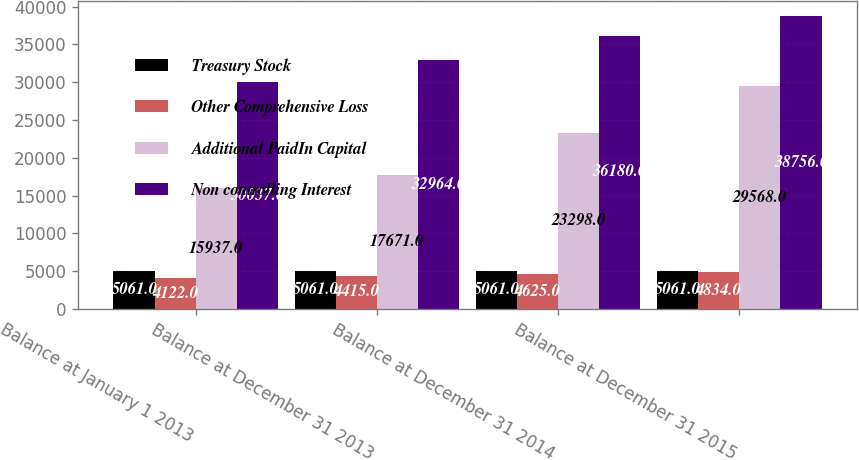Convert chart to OTSL. <chart><loc_0><loc_0><loc_500><loc_500><stacked_bar_chart><ecel><fcel>Balance at January 1 2013<fcel>Balance at December 31 2013<fcel>Balance at December 31 2014<fcel>Balance at December 31 2015<nl><fcel>Treasury Stock<fcel>5061<fcel>5061<fcel>5061<fcel>5061<nl><fcel>Other Comprehensive Loss<fcel>4122<fcel>4415<fcel>4625<fcel>4834<nl><fcel>Additional PaidIn Capital<fcel>15937<fcel>17671<fcel>23298<fcel>29568<nl><fcel>Non controlling Interest<fcel>30037<fcel>32964<fcel>36180<fcel>38756<nl></chart> 